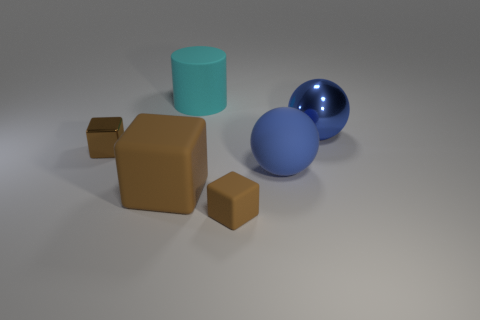Subtract all brown blocks. How many were subtracted if there are1brown blocks left? 2 Add 2 large cubes. How many objects exist? 8 Subtract all balls. How many objects are left? 4 Subtract all matte objects. Subtract all cyan cylinders. How many objects are left? 1 Add 4 matte things. How many matte things are left? 8 Add 5 large spheres. How many large spheres exist? 7 Subtract 2 blue balls. How many objects are left? 4 